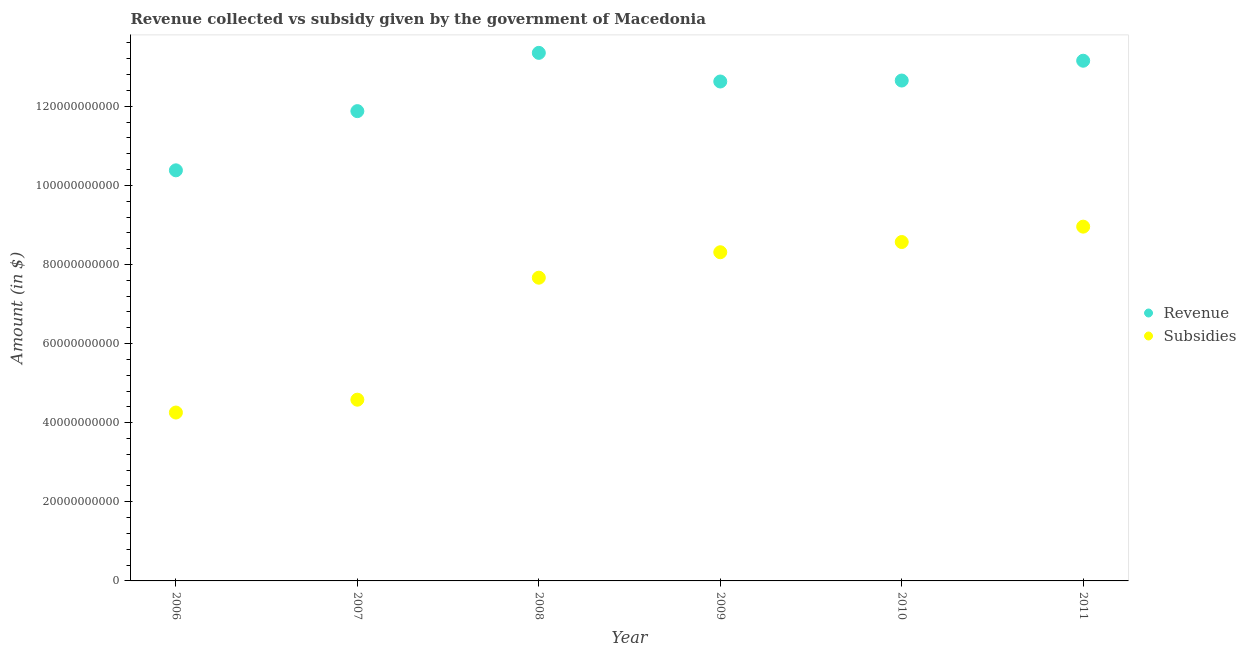How many different coloured dotlines are there?
Make the answer very short. 2. What is the amount of revenue collected in 2006?
Offer a terse response. 1.04e+11. Across all years, what is the maximum amount of revenue collected?
Your response must be concise. 1.34e+11. Across all years, what is the minimum amount of subsidies given?
Give a very brief answer. 4.26e+1. In which year was the amount of subsidies given maximum?
Offer a terse response. 2011. What is the total amount of subsidies given in the graph?
Your answer should be very brief. 4.23e+11. What is the difference between the amount of subsidies given in 2006 and that in 2007?
Give a very brief answer. -3.25e+09. What is the difference between the amount of revenue collected in 2011 and the amount of subsidies given in 2007?
Your answer should be very brief. 8.57e+1. What is the average amount of revenue collected per year?
Your answer should be very brief. 1.23e+11. In the year 2008, what is the difference between the amount of subsidies given and amount of revenue collected?
Keep it short and to the point. -5.68e+1. In how many years, is the amount of subsidies given greater than 28000000000 $?
Provide a short and direct response. 6. What is the ratio of the amount of revenue collected in 2010 to that in 2011?
Keep it short and to the point. 0.96. Is the amount of revenue collected in 2007 less than that in 2010?
Your response must be concise. Yes. Is the difference between the amount of subsidies given in 2007 and 2010 greater than the difference between the amount of revenue collected in 2007 and 2010?
Give a very brief answer. No. What is the difference between the highest and the second highest amount of subsidies given?
Give a very brief answer. 3.89e+09. What is the difference between the highest and the lowest amount of subsidies given?
Offer a very short reply. 4.70e+1. Is the amount of subsidies given strictly less than the amount of revenue collected over the years?
Give a very brief answer. Yes. How many dotlines are there?
Ensure brevity in your answer.  2. What is the difference between two consecutive major ticks on the Y-axis?
Provide a short and direct response. 2.00e+1. Does the graph contain grids?
Give a very brief answer. No. How are the legend labels stacked?
Give a very brief answer. Vertical. What is the title of the graph?
Provide a succinct answer. Revenue collected vs subsidy given by the government of Macedonia. Does "Crop" appear as one of the legend labels in the graph?
Ensure brevity in your answer.  No. What is the label or title of the X-axis?
Provide a succinct answer. Year. What is the label or title of the Y-axis?
Keep it short and to the point. Amount (in $). What is the Amount (in $) of Revenue in 2006?
Provide a short and direct response. 1.04e+11. What is the Amount (in $) in Subsidies in 2006?
Offer a very short reply. 4.26e+1. What is the Amount (in $) of Revenue in 2007?
Keep it short and to the point. 1.19e+11. What is the Amount (in $) of Subsidies in 2007?
Give a very brief answer. 4.58e+1. What is the Amount (in $) of Revenue in 2008?
Offer a terse response. 1.34e+11. What is the Amount (in $) in Subsidies in 2008?
Keep it short and to the point. 7.67e+1. What is the Amount (in $) of Revenue in 2009?
Offer a terse response. 1.26e+11. What is the Amount (in $) in Subsidies in 2009?
Your response must be concise. 8.31e+1. What is the Amount (in $) in Revenue in 2010?
Provide a short and direct response. 1.27e+11. What is the Amount (in $) of Subsidies in 2010?
Your response must be concise. 8.57e+1. What is the Amount (in $) of Revenue in 2011?
Offer a terse response. 1.32e+11. What is the Amount (in $) in Subsidies in 2011?
Give a very brief answer. 8.96e+1. Across all years, what is the maximum Amount (in $) of Revenue?
Your response must be concise. 1.34e+11. Across all years, what is the maximum Amount (in $) of Subsidies?
Your answer should be compact. 8.96e+1. Across all years, what is the minimum Amount (in $) in Revenue?
Give a very brief answer. 1.04e+11. Across all years, what is the minimum Amount (in $) in Subsidies?
Keep it short and to the point. 4.26e+1. What is the total Amount (in $) in Revenue in the graph?
Provide a short and direct response. 7.40e+11. What is the total Amount (in $) in Subsidies in the graph?
Ensure brevity in your answer.  4.23e+11. What is the difference between the Amount (in $) in Revenue in 2006 and that in 2007?
Ensure brevity in your answer.  -1.50e+1. What is the difference between the Amount (in $) of Subsidies in 2006 and that in 2007?
Give a very brief answer. -3.25e+09. What is the difference between the Amount (in $) of Revenue in 2006 and that in 2008?
Your response must be concise. -2.97e+1. What is the difference between the Amount (in $) of Subsidies in 2006 and that in 2008?
Your answer should be compact. -3.41e+1. What is the difference between the Amount (in $) in Revenue in 2006 and that in 2009?
Offer a very short reply. -2.25e+1. What is the difference between the Amount (in $) of Subsidies in 2006 and that in 2009?
Give a very brief answer. -4.05e+1. What is the difference between the Amount (in $) of Revenue in 2006 and that in 2010?
Your answer should be very brief. -2.27e+1. What is the difference between the Amount (in $) of Subsidies in 2006 and that in 2010?
Offer a terse response. -4.31e+1. What is the difference between the Amount (in $) of Revenue in 2006 and that in 2011?
Ensure brevity in your answer.  -2.77e+1. What is the difference between the Amount (in $) of Subsidies in 2006 and that in 2011?
Your response must be concise. -4.70e+1. What is the difference between the Amount (in $) of Revenue in 2007 and that in 2008?
Ensure brevity in your answer.  -1.47e+1. What is the difference between the Amount (in $) of Subsidies in 2007 and that in 2008?
Your answer should be compact. -3.08e+1. What is the difference between the Amount (in $) in Revenue in 2007 and that in 2009?
Ensure brevity in your answer.  -7.49e+09. What is the difference between the Amount (in $) of Subsidies in 2007 and that in 2009?
Your answer should be compact. -3.73e+1. What is the difference between the Amount (in $) in Revenue in 2007 and that in 2010?
Offer a terse response. -7.73e+09. What is the difference between the Amount (in $) in Subsidies in 2007 and that in 2010?
Provide a succinct answer. -3.99e+1. What is the difference between the Amount (in $) in Revenue in 2007 and that in 2011?
Give a very brief answer. -1.27e+1. What is the difference between the Amount (in $) of Subsidies in 2007 and that in 2011?
Make the answer very short. -4.37e+1. What is the difference between the Amount (in $) of Revenue in 2008 and that in 2009?
Your answer should be very brief. 7.24e+09. What is the difference between the Amount (in $) in Subsidies in 2008 and that in 2009?
Offer a terse response. -6.44e+09. What is the difference between the Amount (in $) in Revenue in 2008 and that in 2010?
Offer a terse response. 7.00e+09. What is the difference between the Amount (in $) in Subsidies in 2008 and that in 2010?
Offer a terse response. -9.02e+09. What is the difference between the Amount (in $) of Revenue in 2008 and that in 2011?
Provide a succinct answer. 1.99e+09. What is the difference between the Amount (in $) in Subsidies in 2008 and that in 2011?
Offer a terse response. -1.29e+1. What is the difference between the Amount (in $) in Revenue in 2009 and that in 2010?
Offer a very short reply. -2.45e+08. What is the difference between the Amount (in $) in Subsidies in 2009 and that in 2010?
Your response must be concise. -2.58e+09. What is the difference between the Amount (in $) in Revenue in 2009 and that in 2011?
Your answer should be compact. -5.25e+09. What is the difference between the Amount (in $) in Subsidies in 2009 and that in 2011?
Provide a short and direct response. -6.47e+09. What is the difference between the Amount (in $) of Revenue in 2010 and that in 2011?
Give a very brief answer. -5.01e+09. What is the difference between the Amount (in $) in Subsidies in 2010 and that in 2011?
Keep it short and to the point. -3.89e+09. What is the difference between the Amount (in $) of Revenue in 2006 and the Amount (in $) of Subsidies in 2007?
Your response must be concise. 5.80e+1. What is the difference between the Amount (in $) of Revenue in 2006 and the Amount (in $) of Subsidies in 2008?
Make the answer very short. 2.71e+1. What is the difference between the Amount (in $) of Revenue in 2006 and the Amount (in $) of Subsidies in 2009?
Give a very brief answer. 2.07e+1. What is the difference between the Amount (in $) in Revenue in 2006 and the Amount (in $) in Subsidies in 2010?
Provide a short and direct response. 1.81e+1. What is the difference between the Amount (in $) in Revenue in 2006 and the Amount (in $) in Subsidies in 2011?
Your answer should be compact. 1.42e+1. What is the difference between the Amount (in $) of Revenue in 2007 and the Amount (in $) of Subsidies in 2008?
Your response must be concise. 4.21e+1. What is the difference between the Amount (in $) of Revenue in 2007 and the Amount (in $) of Subsidies in 2009?
Your response must be concise. 3.57e+1. What is the difference between the Amount (in $) of Revenue in 2007 and the Amount (in $) of Subsidies in 2010?
Make the answer very short. 3.31e+1. What is the difference between the Amount (in $) of Revenue in 2007 and the Amount (in $) of Subsidies in 2011?
Keep it short and to the point. 2.92e+1. What is the difference between the Amount (in $) of Revenue in 2008 and the Amount (in $) of Subsidies in 2009?
Keep it short and to the point. 5.04e+1. What is the difference between the Amount (in $) of Revenue in 2008 and the Amount (in $) of Subsidies in 2010?
Make the answer very short. 4.78e+1. What is the difference between the Amount (in $) in Revenue in 2008 and the Amount (in $) in Subsidies in 2011?
Your response must be concise. 4.39e+1. What is the difference between the Amount (in $) in Revenue in 2009 and the Amount (in $) in Subsidies in 2010?
Your answer should be compact. 4.06e+1. What is the difference between the Amount (in $) in Revenue in 2009 and the Amount (in $) in Subsidies in 2011?
Ensure brevity in your answer.  3.67e+1. What is the difference between the Amount (in $) in Revenue in 2010 and the Amount (in $) in Subsidies in 2011?
Your response must be concise. 3.69e+1. What is the average Amount (in $) of Revenue per year?
Provide a succinct answer. 1.23e+11. What is the average Amount (in $) of Subsidies per year?
Offer a very short reply. 7.06e+1. In the year 2006, what is the difference between the Amount (in $) of Revenue and Amount (in $) of Subsidies?
Make the answer very short. 6.12e+1. In the year 2007, what is the difference between the Amount (in $) in Revenue and Amount (in $) in Subsidies?
Your answer should be compact. 7.30e+1. In the year 2008, what is the difference between the Amount (in $) of Revenue and Amount (in $) of Subsidies?
Your answer should be very brief. 5.68e+1. In the year 2009, what is the difference between the Amount (in $) of Revenue and Amount (in $) of Subsidies?
Give a very brief answer. 4.32e+1. In the year 2010, what is the difference between the Amount (in $) of Revenue and Amount (in $) of Subsidies?
Offer a very short reply. 4.08e+1. In the year 2011, what is the difference between the Amount (in $) in Revenue and Amount (in $) in Subsidies?
Ensure brevity in your answer.  4.19e+1. What is the ratio of the Amount (in $) of Revenue in 2006 to that in 2007?
Provide a succinct answer. 0.87. What is the ratio of the Amount (in $) of Subsidies in 2006 to that in 2007?
Your answer should be compact. 0.93. What is the ratio of the Amount (in $) of Revenue in 2006 to that in 2008?
Your answer should be very brief. 0.78. What is the ratio of the Amount (in $) in Subsidies in 2006 to that in 2008?
Your response must be concise. 0.56. What is the ratio of the Amount (in $) in Revenue in 2006 to that in 2009?
Offer a very short reply. 0.82. What is the ratio of the Amount (in $) of Subsidies in 2006 to that in 2009?
Give a very brief answer. 0.51. What is the ratio of the Amount (in $) in Revenue in 2006 to that in 2010?
Give a very brief answer. 0.82. What is the ratio of the Amount (in $) in Subsidies in 2006 to that in 2010?
Your response must be concise. 0.5. What is the ratio of the Amount (in $) in Revenue in 2006 to that in 2011?
Keep it short and to the point. 0.79. What is the ratio of the Amount (in $) of Subsidies in 2006 to that in 2011?
Provide a short and direct response. 0.48. What is the ratio of the Amount (in $) in Revenue in 2007 to that in 2008?
Make the answer very short. 0.89. What is the ratio of the Amount (in $) in Subsidies in 2007 to that in 2008?
Your answer should be very brief. 0.6. What is the ratio of the Amount (in $) in Revenue in 2007 to that in 2009?
Your answer should be compact. 0.94. What is the ratio of the Amount (in $) in Subsidies in 2007 to that in 2009?
Provide a succinct answer. 0.55. What is the ratio of the Amount (in $) in Revenue in 2007 to that in 2010?
Provide a short and direct response. 0.94. What is the ratio of the Amount (in $) in Subsidies in 2007 to that in 2010?
Your answer should be compact. 0.53. What is the ratio of the Amount (in $) in Revenue in 2007 to that in 2011?
Keep it short and to the point. 0.9. What is the ratio of the Amount (in $) of Subsidies in 2007 to that in 2011?
Provide a succinct answer. 0.51. What is the ratio of the Amount (in $) of Revenue in 2008 to that in 2009?
Offer a very short reply. 1.06. What is the ratio of the Amount (in $) of Subsidies in 2008 to that in 2009?
Give a very brief answer. 0.92. What is the ratio of the Amount (in $) in Revenue in 2008 to that in 2010?
Keep it short and to the point. 1.06. What is the ratio of the Amount (in $) in Subsidies in 2008 to that in 2010?
Your answer should be very brief. 0.89. What is the ratio of the Amount (in $) of Revenue in 2008 to that in 2011?
Provide a succinct answer. 1.02. What is the ratio of the Amount (in $) of Subsidies in 2008 to that in 2011?
Your answer should be very brief. 0.86. What is the ratio of the Amount (in $) of Subsidies in 2009 to that in 2010?
Give a very brief answer. 0.97. What is the ratio of the Amount (in $) of Revenue in 2009 to that in 2011?
Provide a short and direct response. 0.96. What is the ratio of the Amount (in $) of Subsidies in 2009 to that in 2011?
Keep it short and to the point. 0.93. What is the ratio of the Amount (in $) in Revenue in 2010 to that in 2011?
Offer a very short reply. 0.96. What is the ratio of the Amount (in $) in Subsidies in 2010 to that in 2011?
Give a very brief answer. 0.96. What is the difference between the highest and the second highest Amount (in $) of Revenue?
Offer a terse response. 1.99e+09. What is the difference between the highest and the second highest Amount (in $) in Subsidies?
Offer a very short reply. 3.89e+09. What is the difference between the highest and the lowest Amount (in $) of Revenue?
Your response must be concise. 2.97e+1. What is the difference between the highest and the lowest Amount (in $) of Subsidies?
Provide a succinct answer. 4.70e+1. 